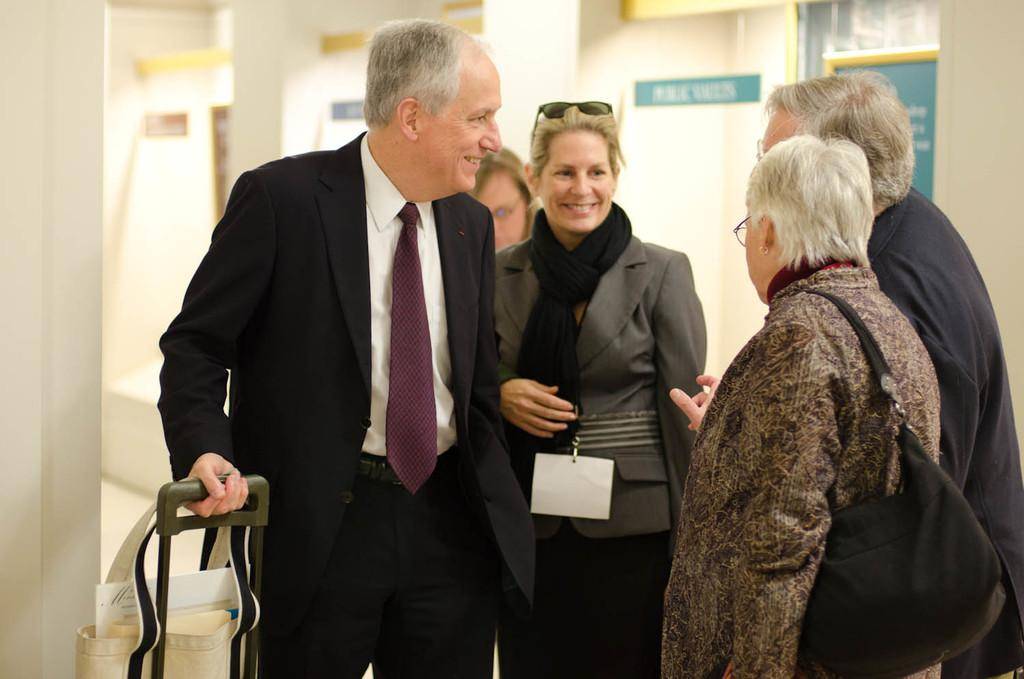What can be seen in the foreground of the image? There are people and bags in the foreground of the image. What else is visible in the foreground besides the people? There are bags visible in the foreground of the image. What can be seen in the background of the image? There are posters on the wall in the background of the image. What type of whip is being used by the people in the image? There is no whip present in the image; the people are not using any whips. What fact can be learned about the posters on the wall in the image? The provided facts do not give any specific information about the posters, so we cannot determine any facts about them. 